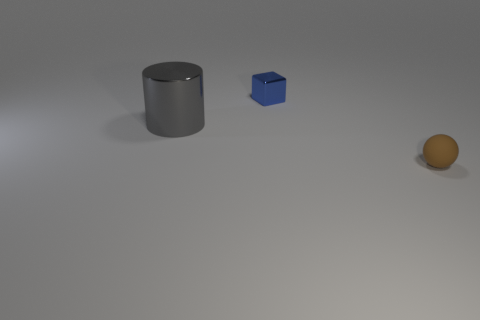Add 3 blue shiny blocks. How many objects exist? 6 Add 1 small blue rubber blocks. How many small blue rubber blocks exist? 1 Subtract 0 green cylinders. How many objects are left? 3 Subtract all cylinders. How many objects are left? 2 Subtract all cyan balls. Subtract all brown cubes. How many balls are left? 1 Subtract all large blue rubber blocks. Subtract all tiny blue metal cubes. How many objects are left? 2 Add 3 cubes. How many cubes are left? 4 